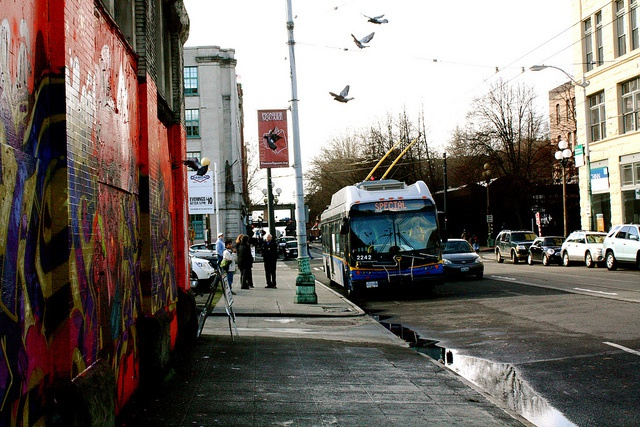Describe the objects in this image and their specific colors. I can see bus in brown, black, blue, gray, and lightgray tones, car in brown, black, navy, darkgray, and blue tones, car in brown, white, black, darkgray, and lightblue tones, car in brown, white, black, darkgray, and gray tones, and car in brown, black, gray, darkgray, and olive tones in this image. 